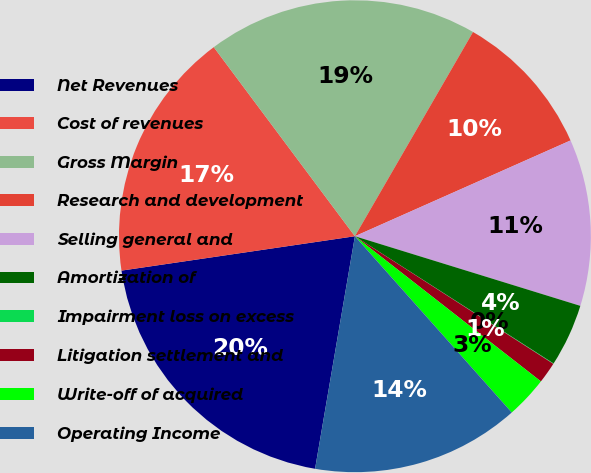<chart> <loc_0><loc_0><loc_500><loc_500><pie_chart><fcel>Net Revenues<fcel>Cost of revenues<fcel>Gross Margin<fcel>Research and development<fcel>Selling general and<fcel>Amortization of<fcel>Impairment loss on excess<fcel>Litigation settlement and<fcel>Write-off of acquired<fcel>Operating Income<nl><fcel>19.97%<fcel>17.12%<fcel>18.55%<fcel>10.0%<fcel>11.42%<fcel>4.3%<fcel>0.03%<fcel>1.45%<fcel>2.88%<fcel>14.27%<nl></chart> 